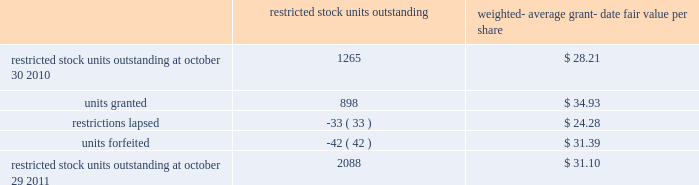The total intrinsic value of options exercised ( i.e .
The difference between the market price at exercise and the price paid by the employee to exercise the options ) during fiscal 2011 , 2010 and 2009 was $ 96.5 million , $ 29.6 million and $ 4.7 million , respectively .
The total amount of proceeds received by the company from exercise of these options during fiscal 2011 , 2010 and 2009 was $ 217.4 million , $ 240.4 million and $ 15.1 million , respectively .
Proceeds from stock option exercises pursuant to employee stock plans in the company 2019s statement of cash flows of $ 217.2 million , $ 216.1 million and $ 12.4 million for fiscal 2011 , 2010 and 2009 , respectively , are net of the value of shares surrendered by employees in certain limited circumstances to satisfy the exercise price of options , and to satisfy employee tax obligations upon vesting of restricted stock or restricted stock units and in connection with the exercise of stock options granted to the company 2019s employees under the company 2019s equity compensation plans .
The withholding amount is based on the company 2019s minimum statutory withholding requirement .
A summary of the company 2019s restricted stock unit award activity as of october 29 , 2011 and changes during the year then ended is presented below : restricted outstanding weighted- average grant- date fair value per share .
As of october 29 , 2011 , there was $ 88.6 million of total unrecognized compensation cost related to unvested share-based awards comprised of stock options and restricted stock units .
That cost is expected to be recognized over a weighted-average period of 1.3 years .
The total grant-date fair value of shares that vested during fiscal 2011 , 2010 and 2009 was approximately $ 49.6 million , $ 67.7 million and $ 74.4 million , respectively .
Common stock repurchase program the company 2019s common stock repurchase program has been in place since august 2004 .
In the aggregate , the board of directors has authorized the company to repurchase $ 5 billion of the company 2019s common stock under the program .
Under the program , the company may repurchase outstanding shares of its common stock from time to time in the open market and through privately negotiated transactions .
Unless terminated earlier by resolution of the company 2019s board of directors , the repurchase program will expire when the company has repurchased all shares authorized under the program .
As of october 29 , 2011 , the company had repurchased a total of approximately 125.0 million shares of its common stock for approximately $ 4278.5 million under this program .
An additional $ 721.5 million remains available for repurchase of shares under the current authorized program .
The repurchased shares are held as authorized but unissued shares of common stock .
Any future common stock repurchases will be dependent upon several factors , including the amount of cash available to the company in the united states and the company 2019s financial performance , outlook and liquidity .
The company also from time to time repurchases shares in settlement of employee tax withholding obligations due upon the vesting of restricted stock units , or in certain limited circumstances to satisfy the exercise price of options granted to the company 2019s employees under the company 2019s equity compensation plans .
Analog devices , inc .
Notes to consolidated financial statements 2014 ( continued ) .
What percentage did the intrinsic value increase from 2009 to 2011? 
Rationale: to find the percentage increase one must subtract the amount from the two dates . then one must take the answer and divide it by the initial number of 2009 .
Computations: ((96.5 - 4.7) / 4.7)
Answer: 19.53191. 